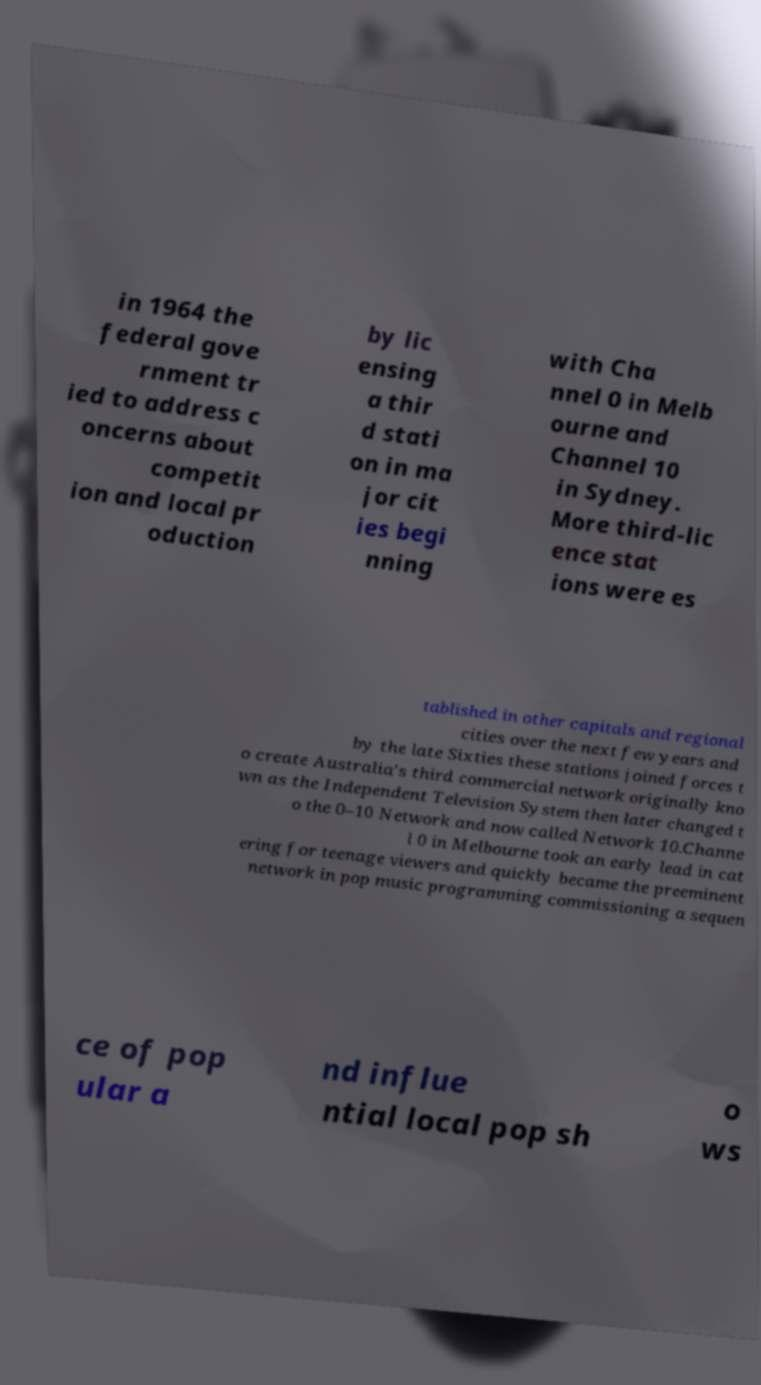I need the written content from this picture converted into text. Can you do that? in 1964 the federal gove rnment tr ied to address c oncerns about competit ion and local pr oduction by lic ensing a thir d stati on in ma jor cit ies begi nning with Cha nnel 0 in Melb ourne and Channel 10 in Sydney. More third-lic ence stat ions were es tablished in other capitals and regional cities over the next few years and by the late Sixties these stations joined forces t o create Australia's third commercial network originally kno wn as the Independent Television System then later changed t o the 0–10 Network and now called Network 10.Channe l 0 in Melbourne took an early lead in cat ering for teenage viewers and quickly became the preeminent network in pop music programming commissioning a sequen ce of pop ular a nd influe ntial local pop sh o ws 